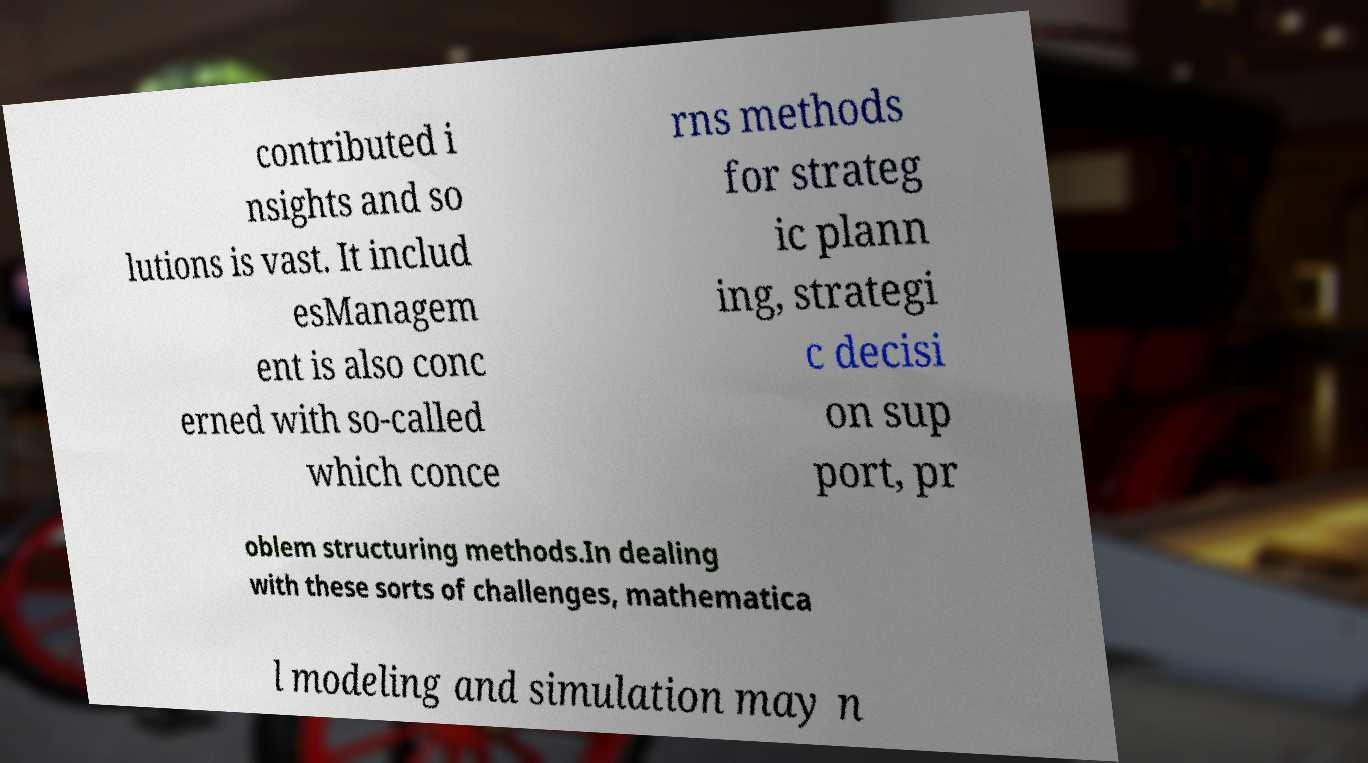Please read and relay the text visible in this image. What does it say? contributed i nsights and so lutions is vast. It includ esManagem ent is also conc erned with so-called which conce rns methods for strateg ic plann ing, strategi c decisi on sup port, pr oblem structuring methods.In dealing with these sorts of challenges, mathematica l modeling and simulation may n 